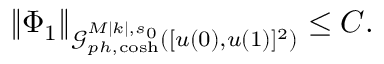Convert formula to latex. <formula><loc_0><loc_0><loc_500><loc_500>\begin{array} { r } { \| \Phi _ { 1 } \| _ { \mathcal { G } _ { p h , \cosh } ^ { M | k | , s _ { 0 } } ( [ u ( 0 ) , u ( 1 ) ] ^ { 2 } ) } \leq C . } \end{array}</formula> 